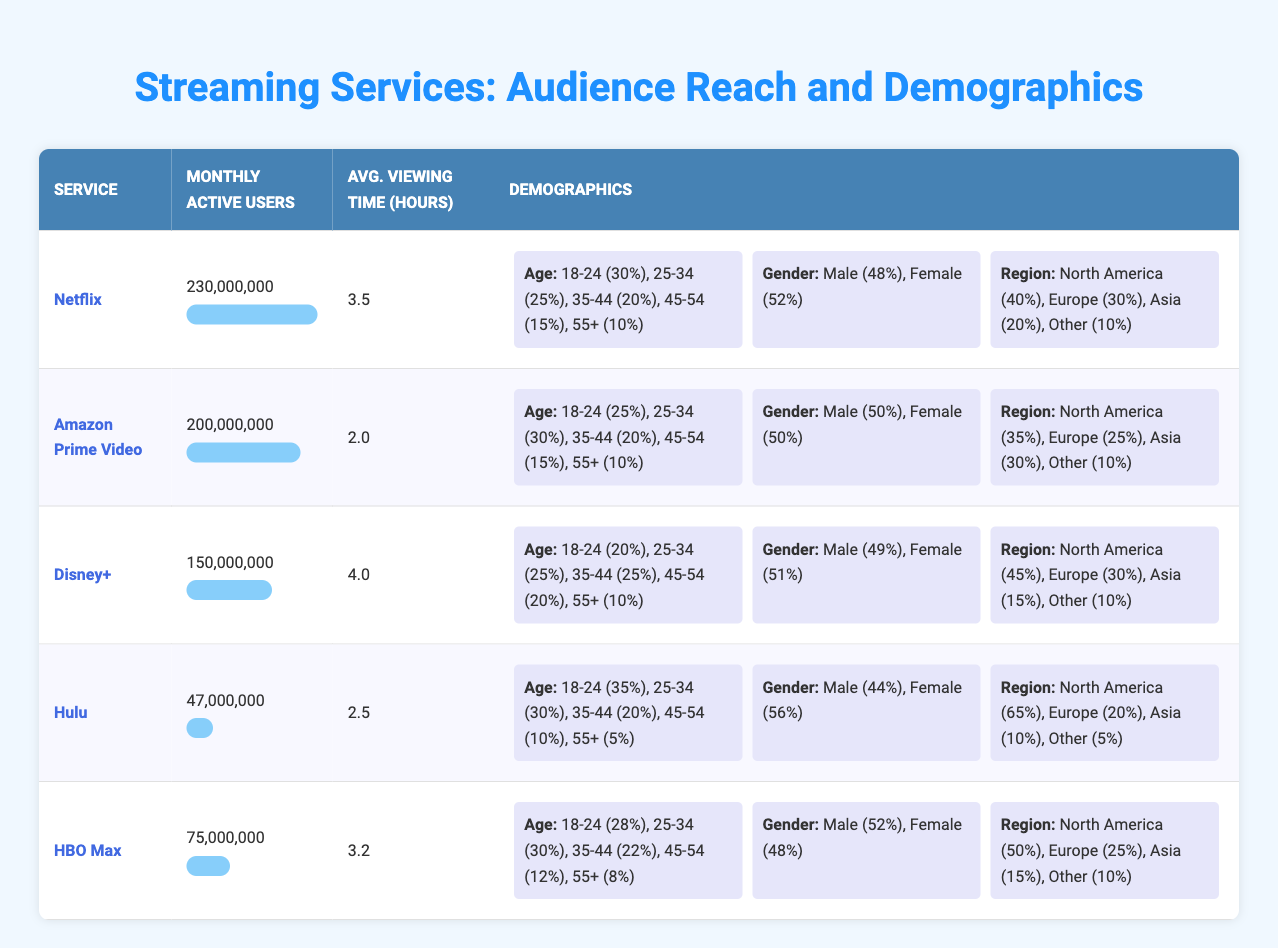What is the monthly active user count for Netflix? The table lists the monthly active user numbers for each streaming service. For Netflix, it shows 230,000,000 active users.
Answer: 230,000,000 Which streaming service has the highest average viewing time per user? By comparing the average viewing times listed in the table, Netflix has 3.5 hours, Disney+ has 4.0 hours, Hulu has 2.5 hours, Amazon Prime Video has 2.0 hours, and HBO Max has 3.2 hours. Disney+ has the highest average viewing time at 4.0 hours.
Answer: Disney+ What percentage of Hulu’s audience falls in the age group of 18-24? The demographics section for Hulu shows that 35% of its audience falls in the 18-24 age group.
Answer: 35% Is it true that Amazon Prime Video has a gender distribution of 50% male and 50% female? The demographics section for Amazon Prime Video shows that the gender distribution is 50% male and 50% female, indicating the statement is true.
Answer: Yes What is the total number of monthly active users across all services? To find the total, sum the monthly active users: 230,000,000 (Netflix) + 200,000,000 (Amazon Prime Video) + 150,000,000 (Disney+) + 47,000,000 (Hulu) + 75,000,000 (HBO Max) = 702,000,000.
Answer: 702,000,000 Which service has the lowest active user count and what is its average viewing time? The table shows that Hulu has the lowest active user count at 47,000,000, with an average viewing time of 2.5 hours per user.
Answer: Hulu, 2.5 hours How does the geographic distribution of Disney+ users compare to that of Netflix in North America? For Disney+, 45% of users are from North America, while Netflix has 40% from the same region, meaning Disney+ has a higher geographic distribution in North America by 5%.
Answer: Disney+ has a higher distribution by 5% What is the average age percentage for the 35-44 age group across all services? The percentages in the 35-44 age group are: Netflix (20%), Amazon Prime Video (20%), Disney+ (25%), Hulu (20%), and HBO Max (22%). The average is (20 + 20 + 25 + 20 + 22) / 5 = 21.4%.
Answer: 21.4% 